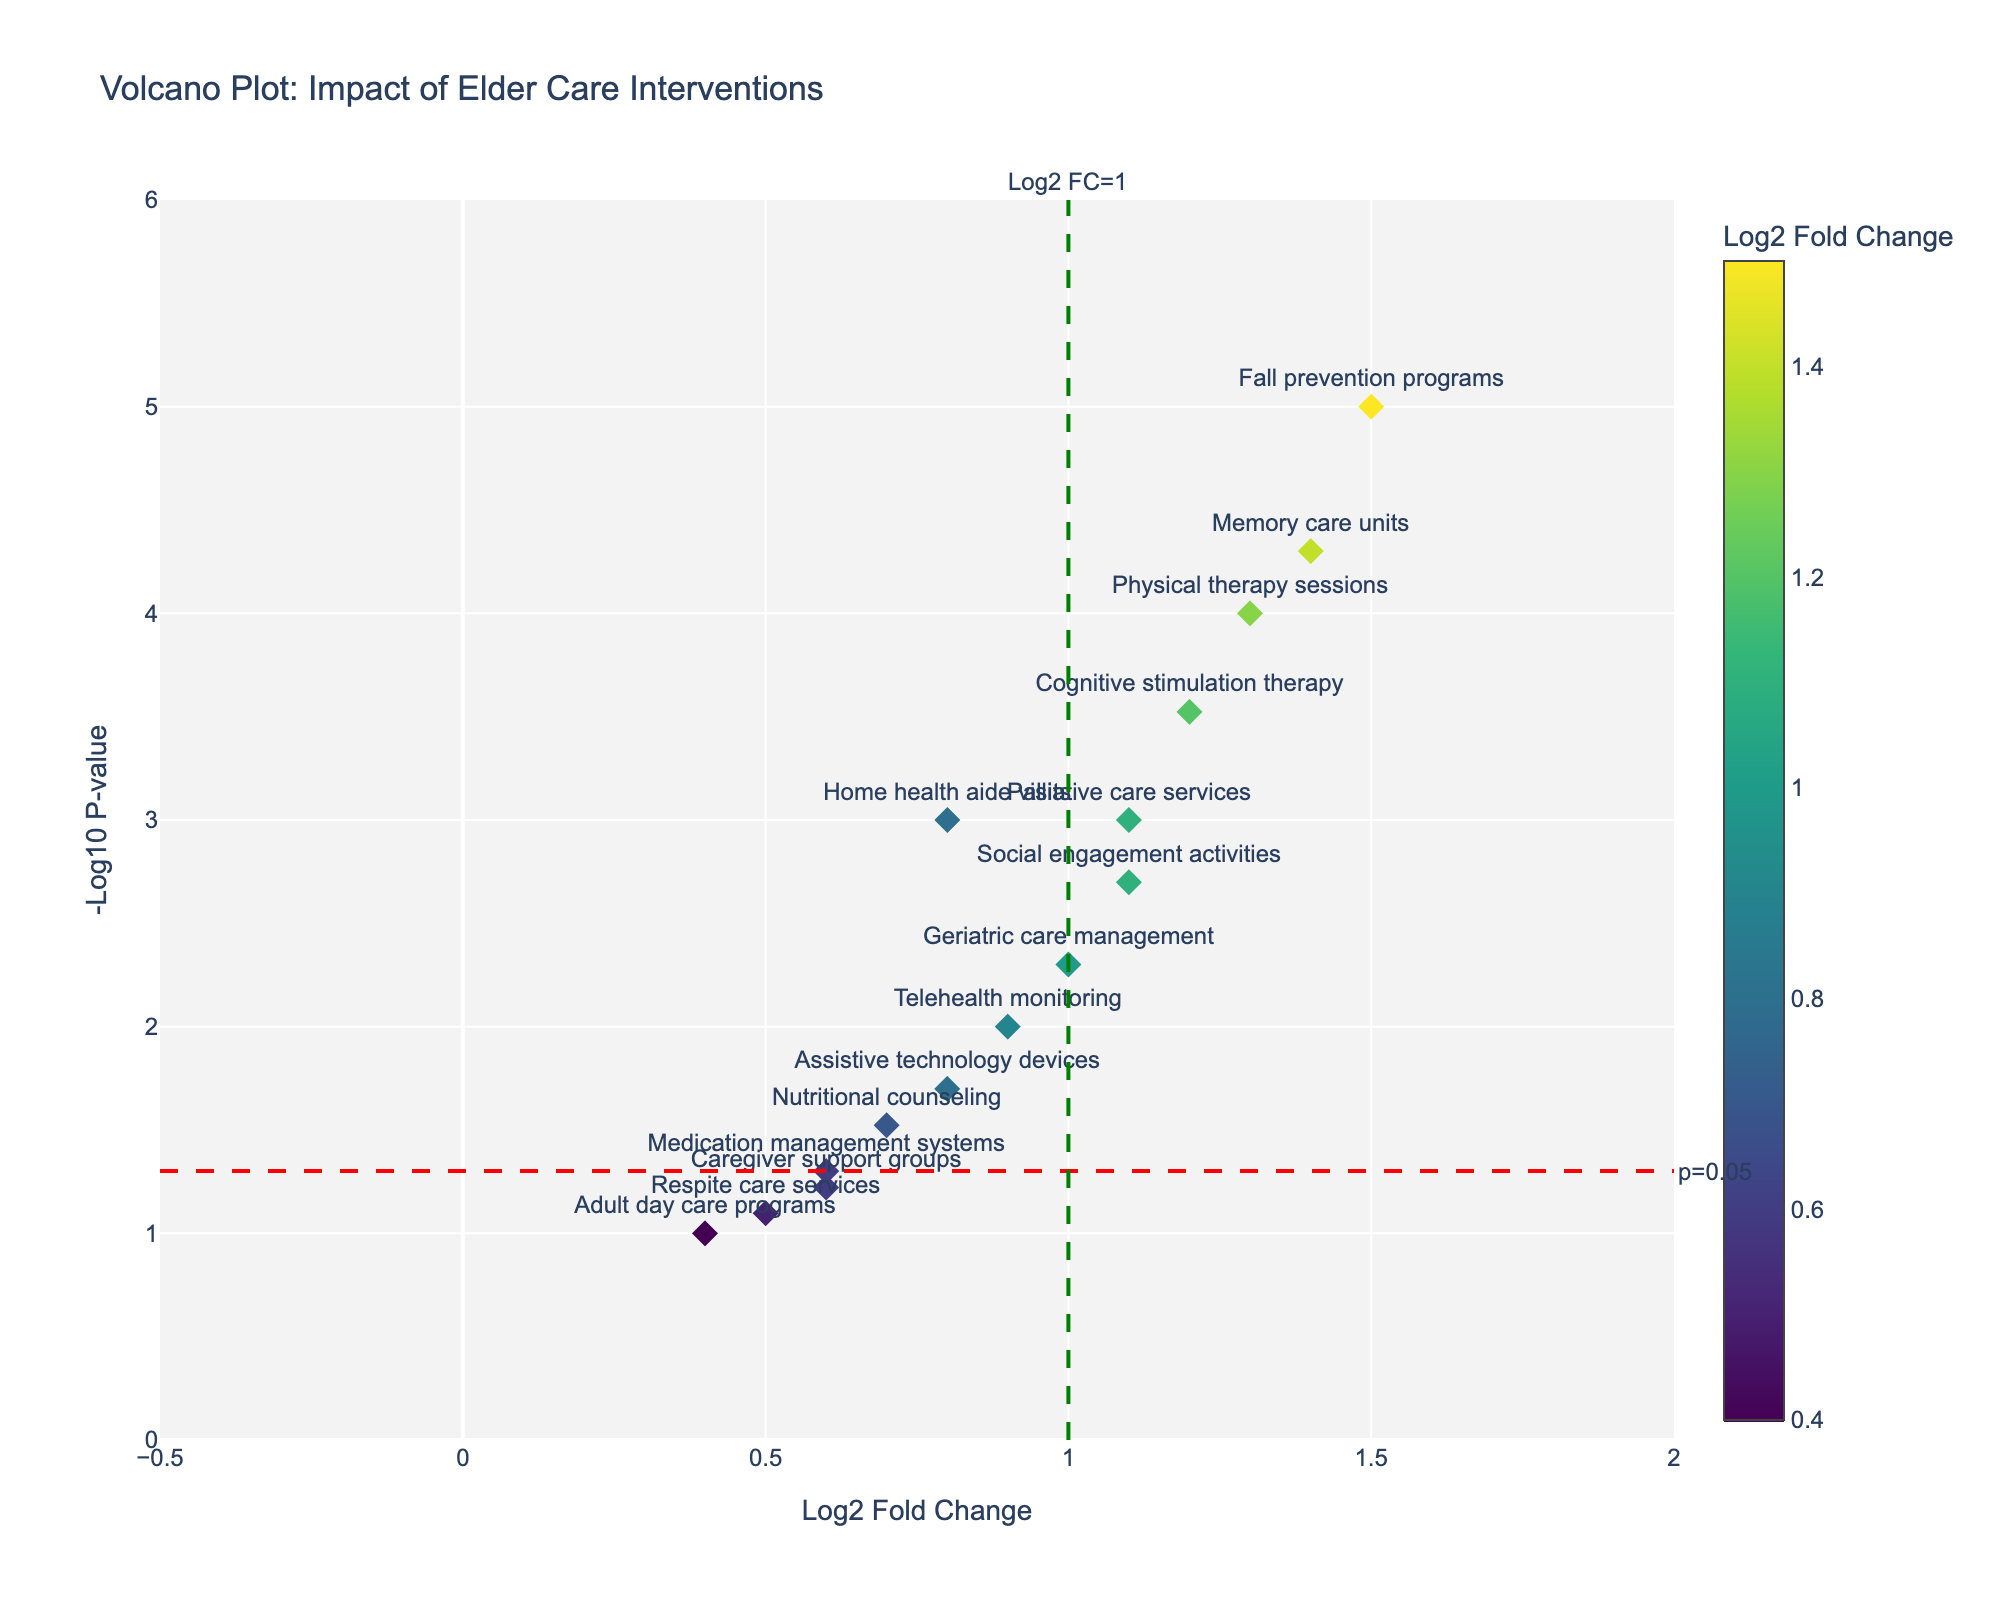What is the title of the figure? The title of the figure is placed at the top of the plot, clearly indicating the subject of the analysis.
Answer: Volcano Plot: Impact of Elder Care Interventions What are the x and y-axis labels? The x and y-axis labels are displayed beside the respective axes of the plot. The x-axis is labeled 'Log2 Fold Change', and the y-axis is labeled '-Log10 P-value'.
Answer: Log2 Fold Change; -Log10 P-value Which intervention has the highest fold change? By examining the intervention that is farthest to the right on the x-axis, we can determine the one with the highest fold change. That intervention is Fall prevention programs at approximately 1.5 on the Log2 Fold Change axis.
Answer: Fall prevention programs How many interventions have a p-value less than 0.05? Interventions with a p-value less than 0.05 are located above the red horizontal threshold line (y = 1.301) on the plot. Counting these points, we get: Home health aide visits, Cognitive stimulation therapy, Fall prevention programs, Telehealth monitoring, Social engagement activities, Physical therapy sessions, Geriatric care management, Memory care units, and Palliative care services making a total of 9 interventions.
Answer: 9 What intervention is closest to the threshold of Log2 Fold Change = 1? By looking near the green vertical line marking Log2 Fold Change = 1, we see that the intervention closest to this line is Geriatric care management.
Answer: Geriatric care management Which interventions are considered highly significant (p-value < 0.01) and also have a positive fold change greater than 1? First, identify the interventions above the red threshold line at y=1.301 (-log10(0.01)) and then check if their Log2 Fold Change is greater than 1. These interventions include Fall prevention programs, Cognitive stimulation therapy, Social engagement activities, Physical therapy sessions, Memory care units, and Palliative care services.
Answer: Fall prevention programs, Cognitive stimulation therapy, Social engagement activities, Physical therapy sessions, Memory care units, Palliative care services Which intervention has the smallest effect size but is statistically significant? We find the interventions with p-values below 0.05 (above the red line) and identify the one with the smallest positive fold change. Respite care services has a Log2 Fold Change of 0.5 and is statistically significant.
Answer: Respite care services Which interventions have a Log2 Fold Change between 0.5 and 1.0? By focusing on the range of 0.5 < Log2 Fold Change < 1.0 on the x-axis of the plot, we identify Home health aide visits, Medication management systems, Nutritional counseling, Respite care services, and Assistive technology devices.
Answer: Home health aide visits, Medication management systems, Nutritional counseling, Respite care services, Assistive technology devices How does the effect size and significance of Memory care units compare to Social engagement activities? Memory care units have a Log2 Fold Change of 1.4 and -Log10 P-value closer to 4.3, whereas Social engagement activities have a Log2 Fold Change of roughly 1.1 and -Log10 P-value of around 2.7. Memory care units have a larger effect size and are more statistically significant than Social engagement activities.
Answer: Memory care units have a larger effect size and higher statistical significance 